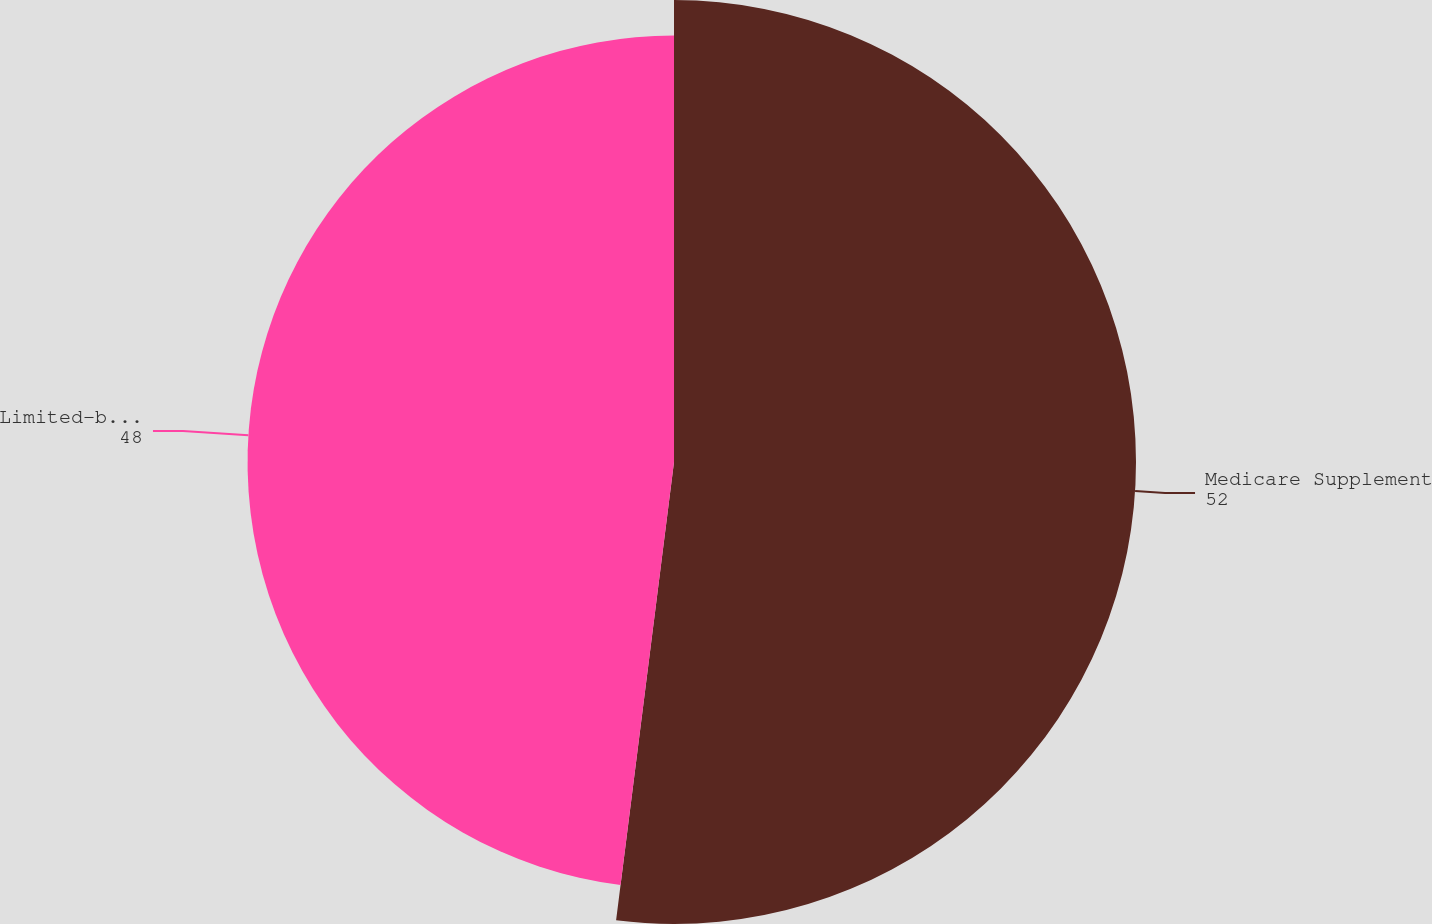Convert chart to OTSL. <chart><loc_0><loc_0><loc_500><loc_500><pie_chart><fcel>Medicare Supplement<fcel>Limited-benefit plans<nl><fcel>52.0%<fcel>48.0%<nl></chart> 